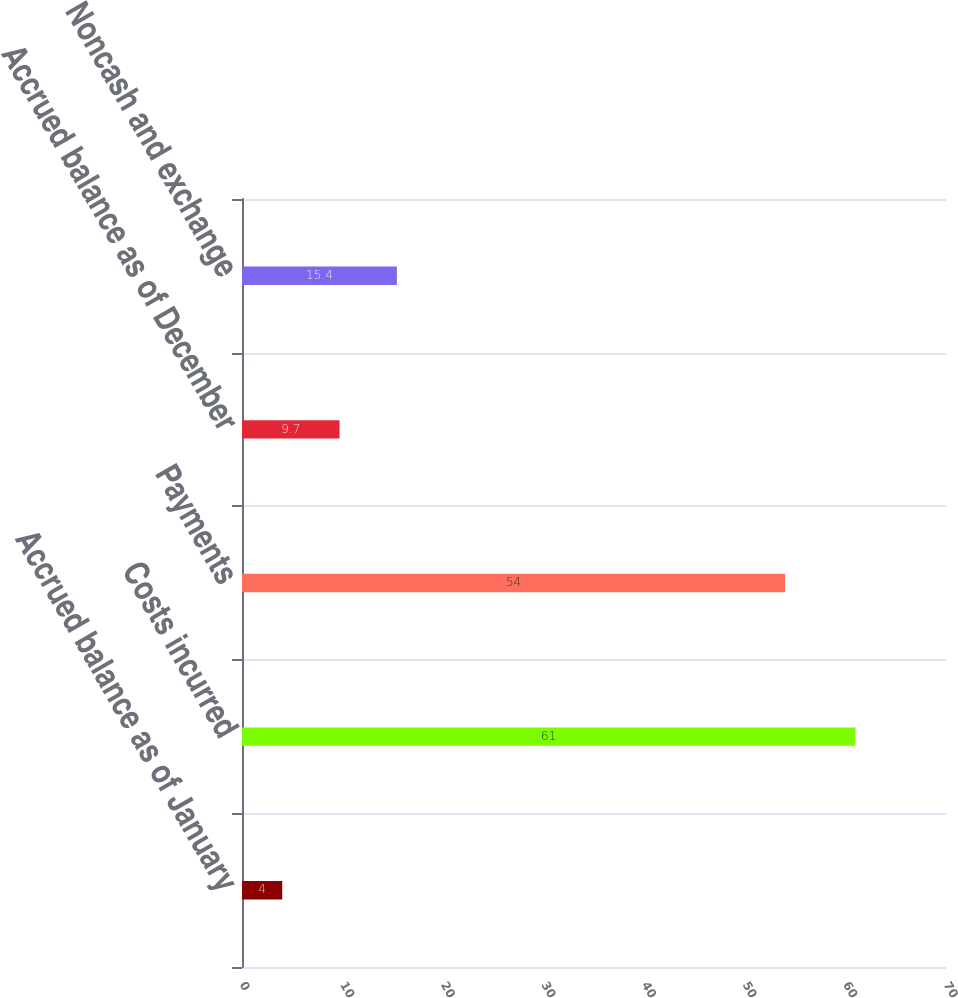Convert chart. <chart><loc_0><loc_0><loc_500><loc_500><bar_chart><fcel>Accrued balance as of January<fcel>Costs incurred<fcel>Payments<fcel>Accrued balance as of December<fcel>Noncash and exchange<nl><fcel>4<fcel>61<fcel>54<fcel>9.7<fcel>15.4<nl></chart> 